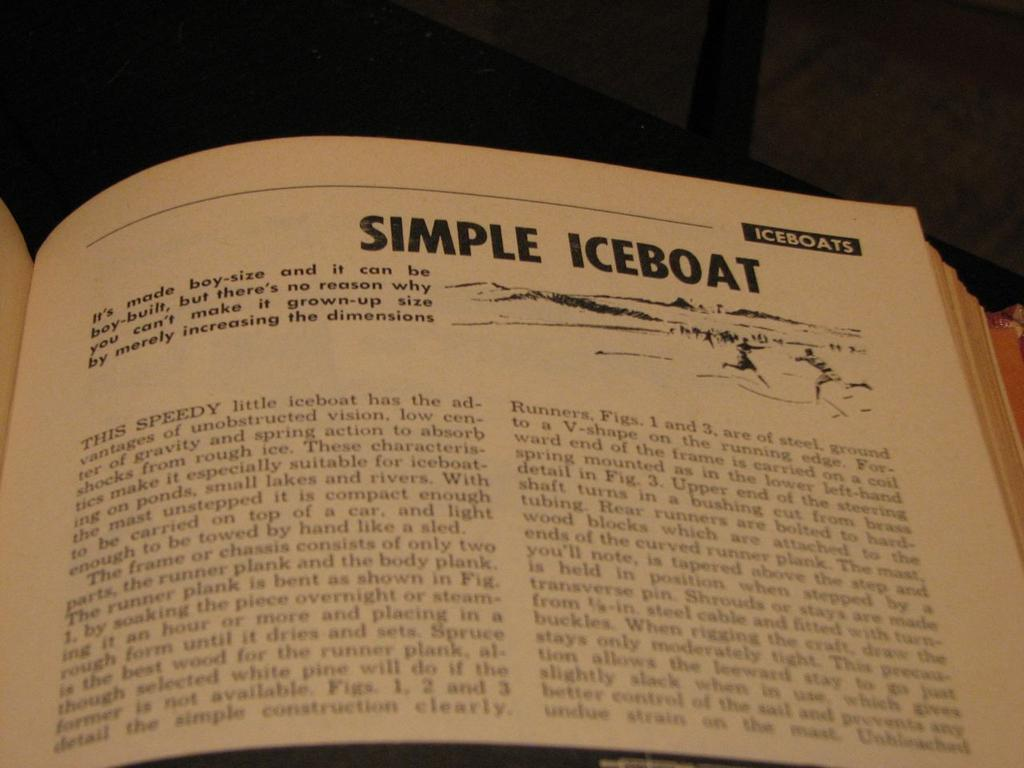What object is present in the image? There is a book in the image. What is the color of the book? The book is cream in color. What is the book placed on? The book is on a black colored surface. What color are the words on the book? The words on the book are written with black color. What type of plants can be seen growing on the book in the image? There are no plants visible on the book in the image. 